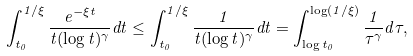<formula> <loc_0><loc_0><loc_500><loc_500>\int ^ { 1 / \xi } _ { t _ { 0 } } \frac { e ^ { - \xi t } } { t ( \log t ) ^ { \gamma } } d t \leq \int ^ { 1 / \xi } _ { t _ { 0 } } \frac { 1 } { t ( \log t ) ^ { \gamma } } d t = \int _ { \log t _ { 0 } } ^ { \log ( 1 / \xi ) } \frac { 1 } { \tau ^ { \gamma } } d \tau ,</formula> 